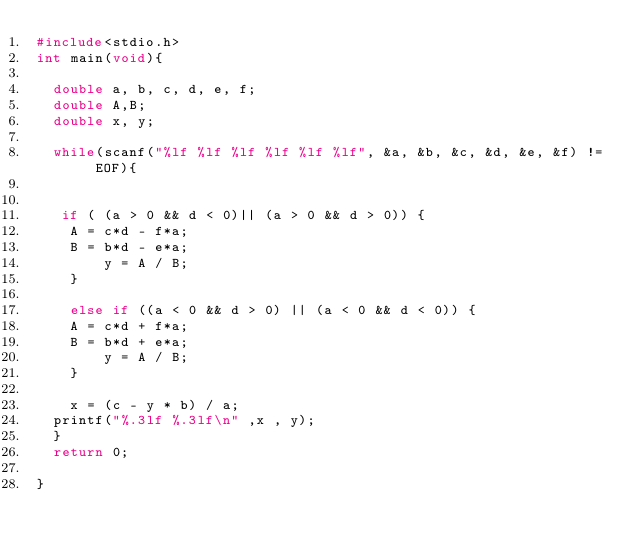Convert code to text. <code><loc_0><loc_0><loc_500><loc_500><_C_>#include<stdio.h>
int main(void){

	double a, b, c, d, e, f;
	double A,B;
	double x, y;

	while(scanf("%lf %lf %lf %lf %lf %lf", &a, &b, &c, &d, &e, &f) != EOF){
		 
	 
	 if ( (a > 0 && d < 0)|| (a > 0 && d > 0)) {
		A = c*d - f*a;
		B = b*d - e*a;
        y = A / B;
    }
    
    else if ((a < 0 && d > 0) || (a < 0 && d < 0)) {
		A = c*d + f*a;
		B = b*d + e*a;
        y = A / B;
    }
	
    x = (c - y * b) / a;
	printf("%.3lf %.3lf\n" ,x , y);
	}
	return 0;

}
</code> 